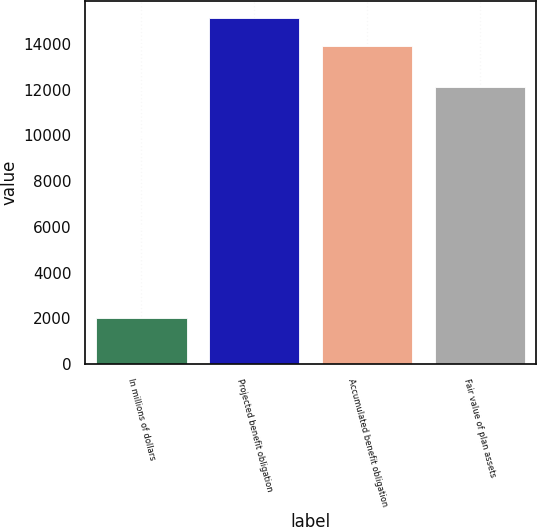Convert chart. <chart><loc_0><loc_0><loc_500><loc_500><bar_chart><fcel>In millions of dollars<fcel>Projected benefit obligation<fcel>Accumulated benefit obligation<fcel>Fair value of plan assets<nl><fcel>2015<fcel>15124.8<fcel>13932<fcel>12137<nl></chart> 